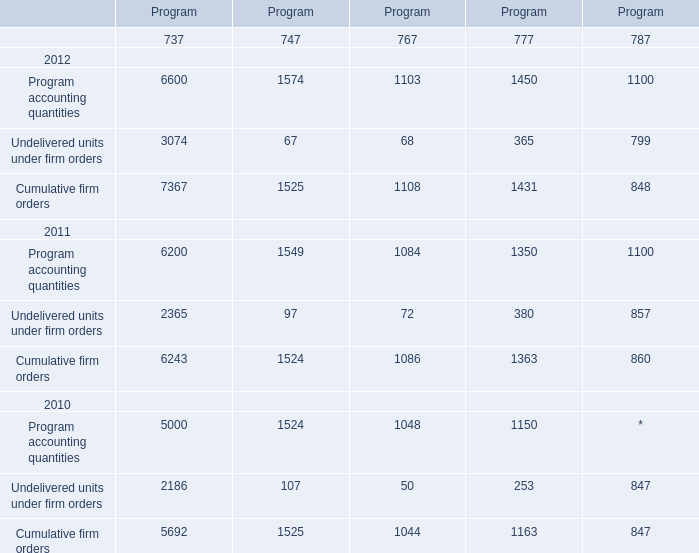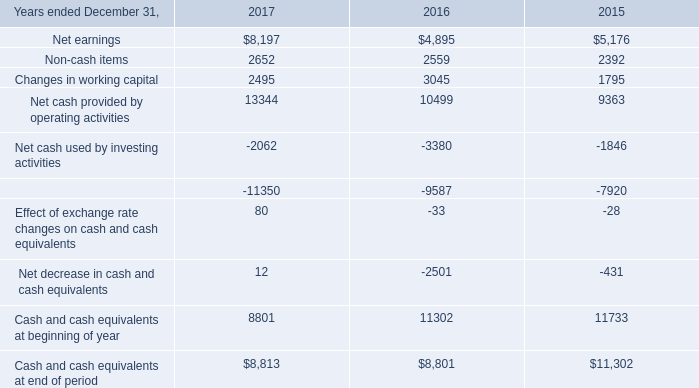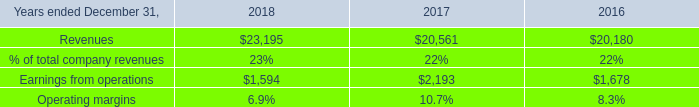How many kinds of Program 737 in 2012 are greater than those in the previous year? 
Answer: 3. 